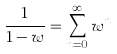Convert formula to latex. <formula><loc_0><loc_0><loc_500><loc_500>\frac { 1 } { 1 - w } = \sum _ { n = 0 } ^ { \infty } w ^ { n }</formula> 